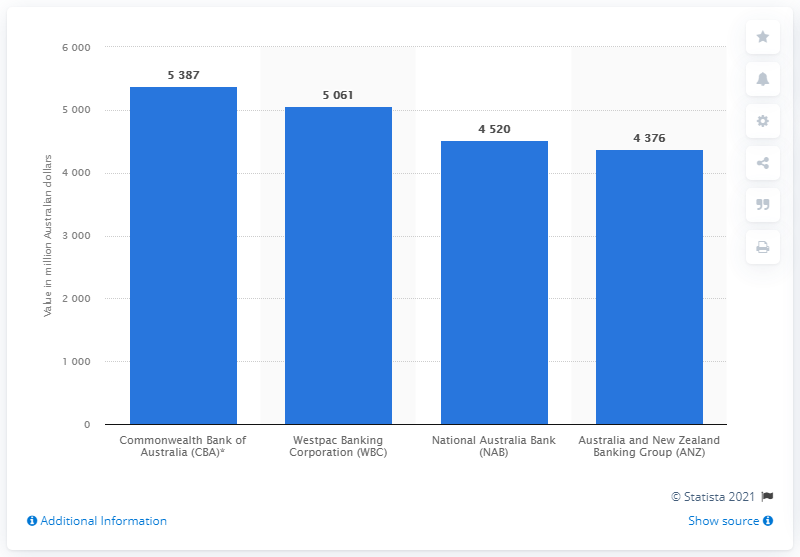Mention a couple of crucial points in this snapshot. The profit before tax of the Commonwealth Bank of Australia as of March 31 was 5,387. 